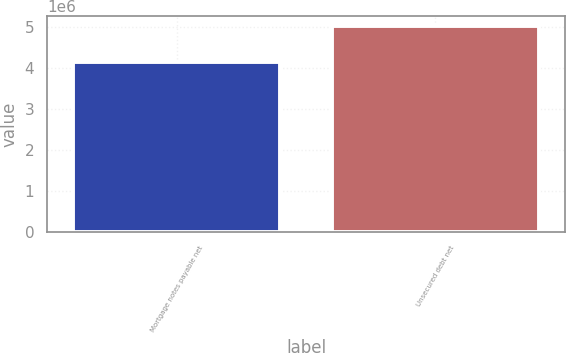Convert chart to OTSL. <chart><loc_0><loc_0><loc_500><loc_500><bar_chart><fcel>Mortgage notes payable net<fcel>Unsecured debt net<nl><fcel>4.161e+06<fcel>5.03033e+06<nl></chart> 